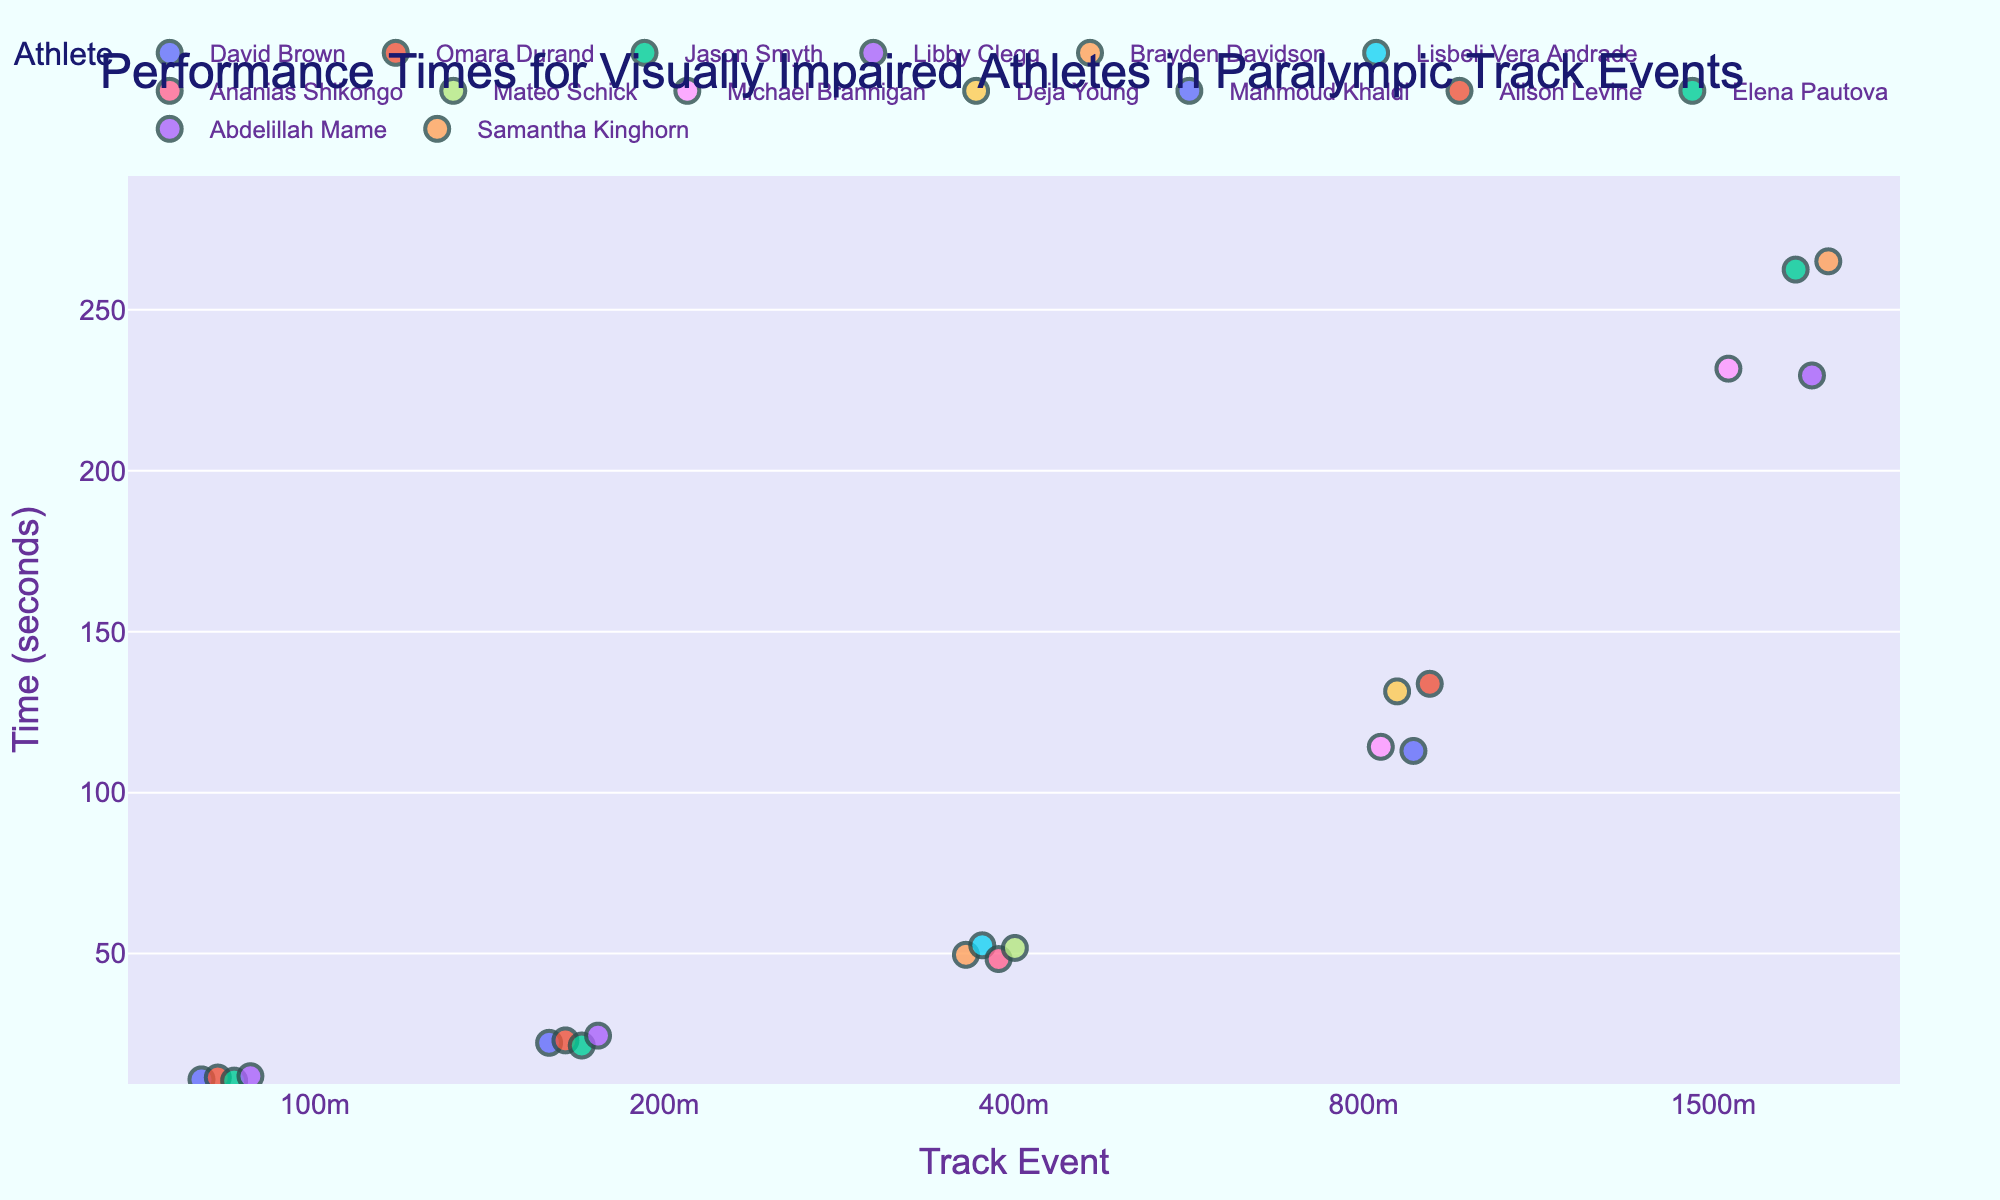What title is given to the figure? The title is displayed prominently at the top of the figure.
Answer: Performance Times for Visually Impaired Athletes in Paralympic Track Events How many different track events are represented in the figure? The x-axis of the figure displays the different track events as categories. Counting them yields a total of 5 events.
Answer: 5 Which athlete has the fastest time in the 100m event? Locate the 100m event on the x-axis, then identify the lowest point (fastest time) on the y-axis for that event and check the color legend to identify the athlete.
Answer: Jason Smyth What is the range of times for the 400m event? Locate the 400m event on the x-axis, then find the highest and lowest points on the y-axis for that event. Subtract the lowest value from the highest value.
Answer: 52.58 - 48.31 = 4.27 seconds Which event shows the most variation in performance times? Compare the spread of points along the y-axis for each event and identify the event with the widest spread of times.
Answer: 800m How does David Brown's performance in the 100m compare to his performance in the 200m? Locate David Brown's points for both the 100m and 200m events and compare their positions on the y-axis. The lower the point, the faster the time.
Answer: David Brown is faster in the 100m In which event does Omara Durand have her fastest time? Locate Omara Durand's points for each event and find the lowest point on the y-axis to identify her fastest time event.
Answer: 100m Which female athlete has the fastest time in the 1500m event? Locate the 1500m event, then find the lowest point for female athletes and check the color legend to identify her.
Answer: Elena Pautova What is the difference in time between the fastest and slowest athletes in the 800m event? Locate the 800m event and find the fastest (lowest point) and slowest (highest point) times, then subtract the fastest time from the slowest time.
Answer: 2:13.82 - 1:52.96 = 20.86 seconds Is there any event where two athletes have the same time? Scan through the points for each event and check if any points overlap exactly on the y-axis for the same event.
Answer: No 